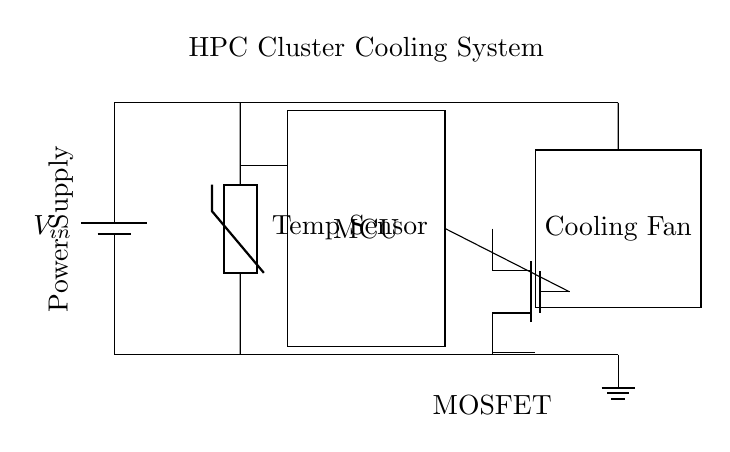What is the main component controlling the fan? The main component controlling the fan is the MOSFET, which acts as a switch to regulate the power supplied to the fan based on signals from the microcontroller.
Answer: MOSFET What is the role of the temperature sensor in the circuit? The temperature sensor provides feedback to the microcontroller about the ambient temperature, allowing it to make informed decisions about the operation of the cooling fan to maintain optimal temperature.
Answer: Feedback How many main blocks are present in the circuit? The circuit has four main blocks: the power supply, temperature sensor, microcontroller, and cooling fan. Each block serves a specific function to support the temperature control system in the HPC cluster.
Answer: Four What is the supply voltage denoted as in the circuit? The supply voltage in the circuit is denoted as V in, indicating the input voltage provided to power the system components including the fan and microcontroller.
Answer: V in What does the MCU do in relation to the cooling system? The MCU processes the temperature data received from the sensor and sends a control signal to the MOSFET, which regulates the operation of the cooling fan to manage the temperature effectively.
Answer: Process What happens when the temperature increases beyond the threshold? When the temperature increases beyond the set threshold, the MCU activates the MOSFET, which allows current to flow to the cooling fan, turning it on to lower the temperature of the HPC cluster.
Answer: Activates fan 